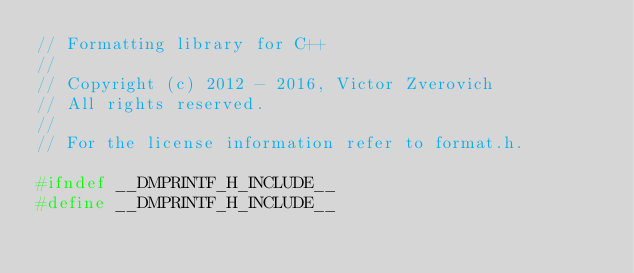Convert code to text. <code><loc_0><loc_0><loc_500><loc_500><_C_>// Formatting library for C++
//
// Copyright (c) 2012 - 2016, Victor Zverovich
// All rights reserved.
//
// For the license information refer to format.h.

#ifndef __DMPRINTF_H_INCLUDE__
#define __DMPRINTF_H_INCLUDE__
</code> 